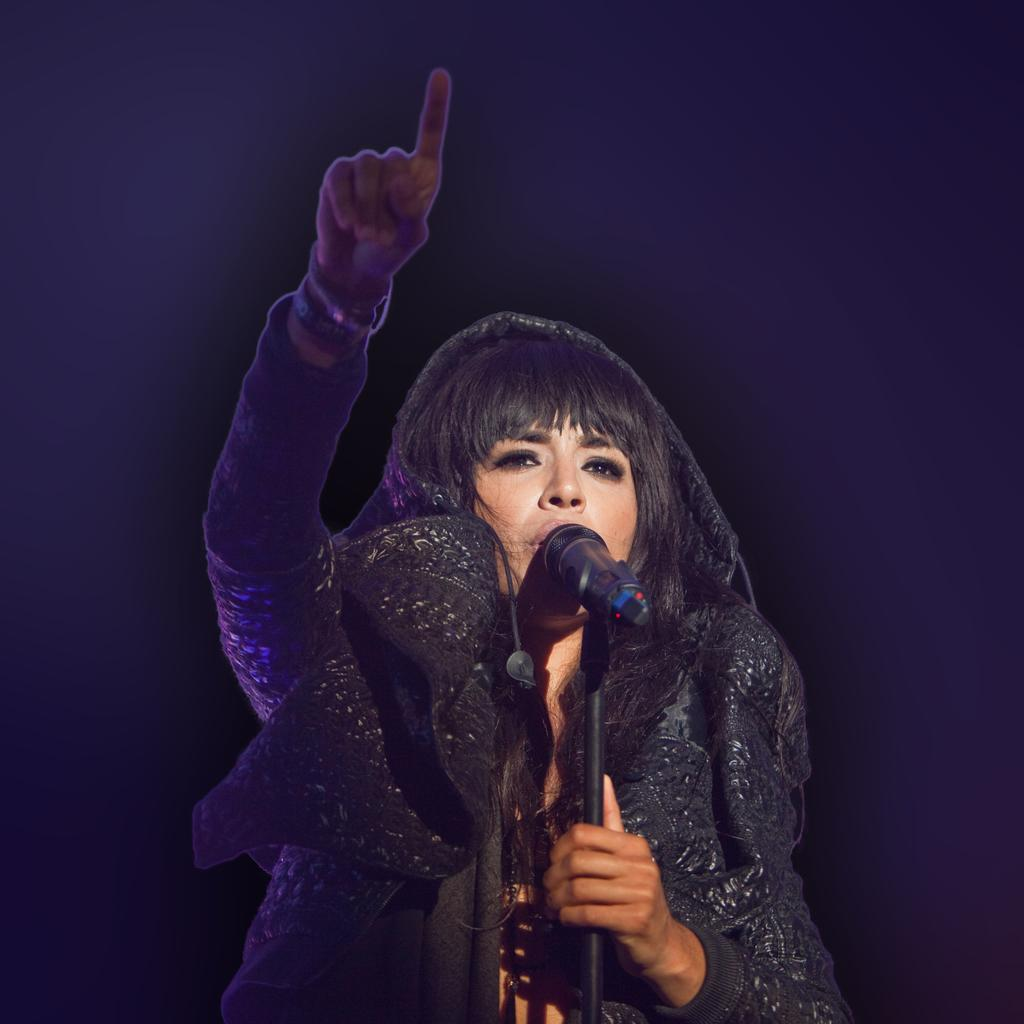Who is the main subject in the picture? There is a woman in the picture. What object is visible in the image? There is a microphone present in the image. How is the microphone positioned in the image? The microphone is on a stand. What type of servant is attending to the woman in the image? There is no servant present in the image. What type of dinner is being served in the image? There is no dinner present in the image. 